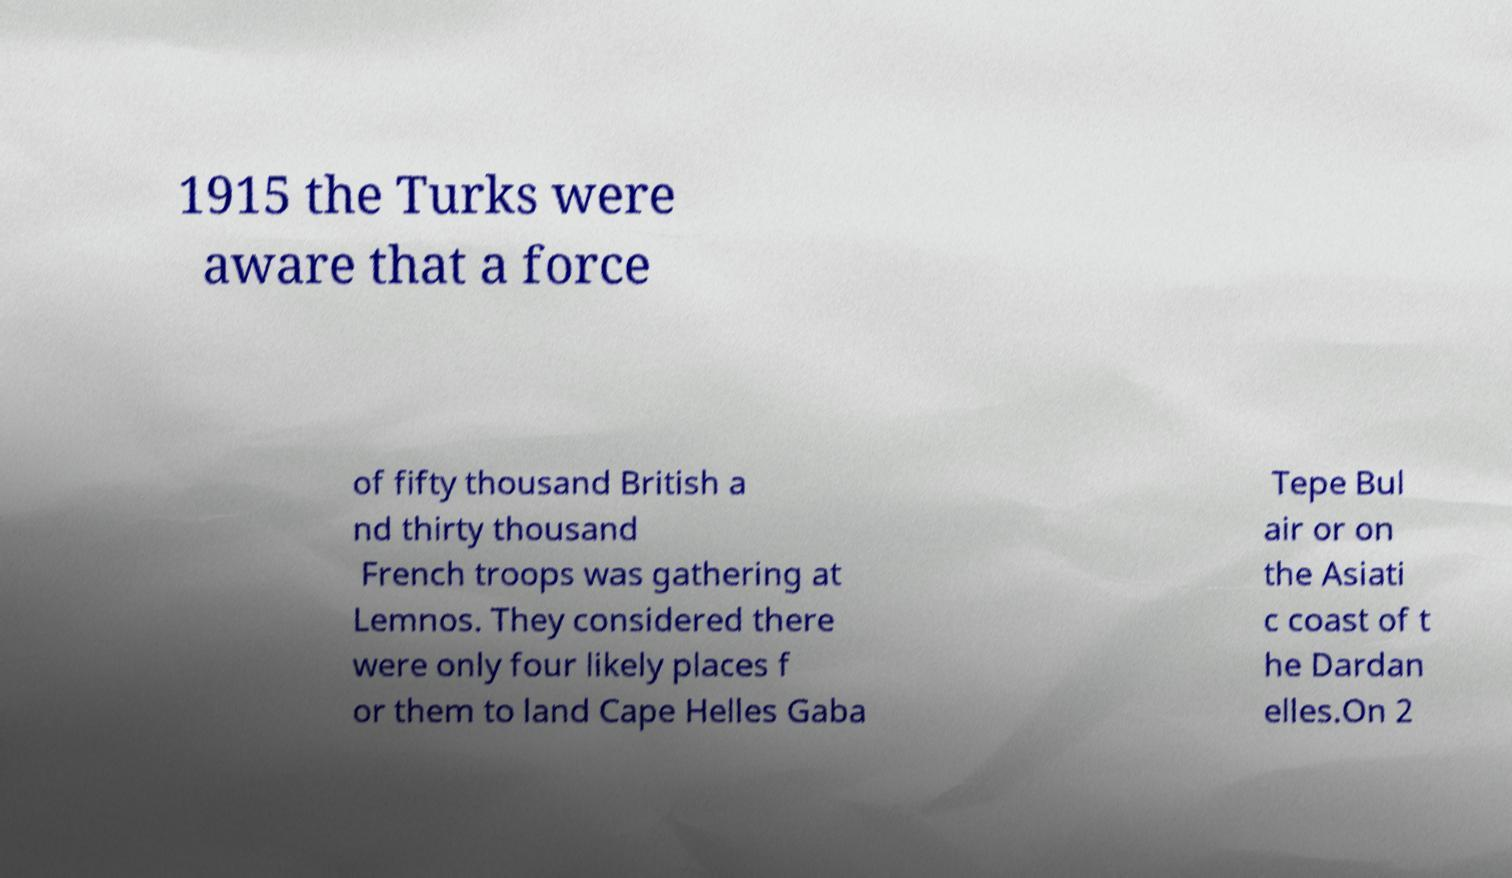Can you read and provide the text displayed in the image?This photo seems to have some interesting text. Can you extract and type it out for me? 1915 the Turks were aware that a force of fifty thousand British a nd thirty thousand French troops was gathering at Lemnos. They considered there were only four likely places f or them to land Cape Helles Gaba Tepe Bul air or on the Asiati c coast of t he Dardan elles.On 2 